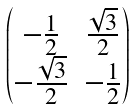Convert formula to latex. <formula><loc_0><loc_0><loc_500><loc_500>\begin{pmatrix} - \frac { 1 } { 2 } & \frac { \sqrt { 3 } } { 2 } \\ - \frac { \sqrt { 3 } } { 2 } & - \frac { 1 } { 2 } \end{pmatrix}</formula> 